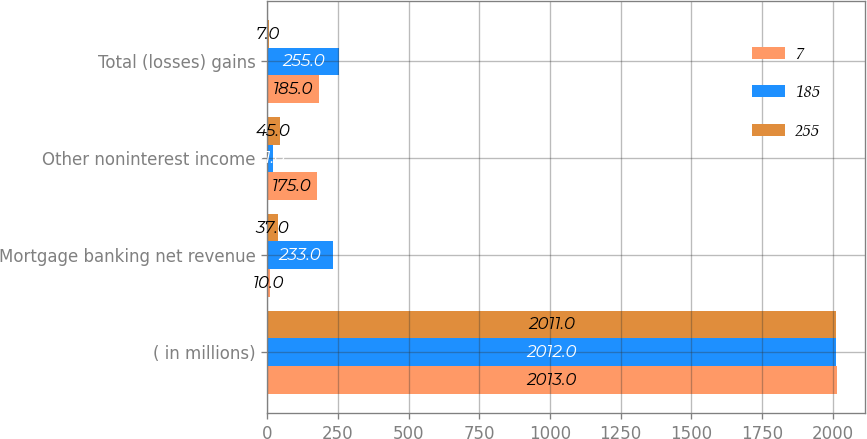<chart> <loc_0><loc_0><loc_500><loc_500><stacked_bar_chart><ecel><fcel>( in millions)<fcel>Mortgage banking net revenue<fcel>Other noninterest income<fcel>Total (losses) gains<nl><fcel>7<fcel>2013<fcel>10<fcel>175<fcel>185<nl><fcel>185<fcel>2012<fcel>233<fcel>21<fcel>255<nl><fcel>255<fcel>2011<fcel>37<fcel>45<fcel>7<nl></chart> 